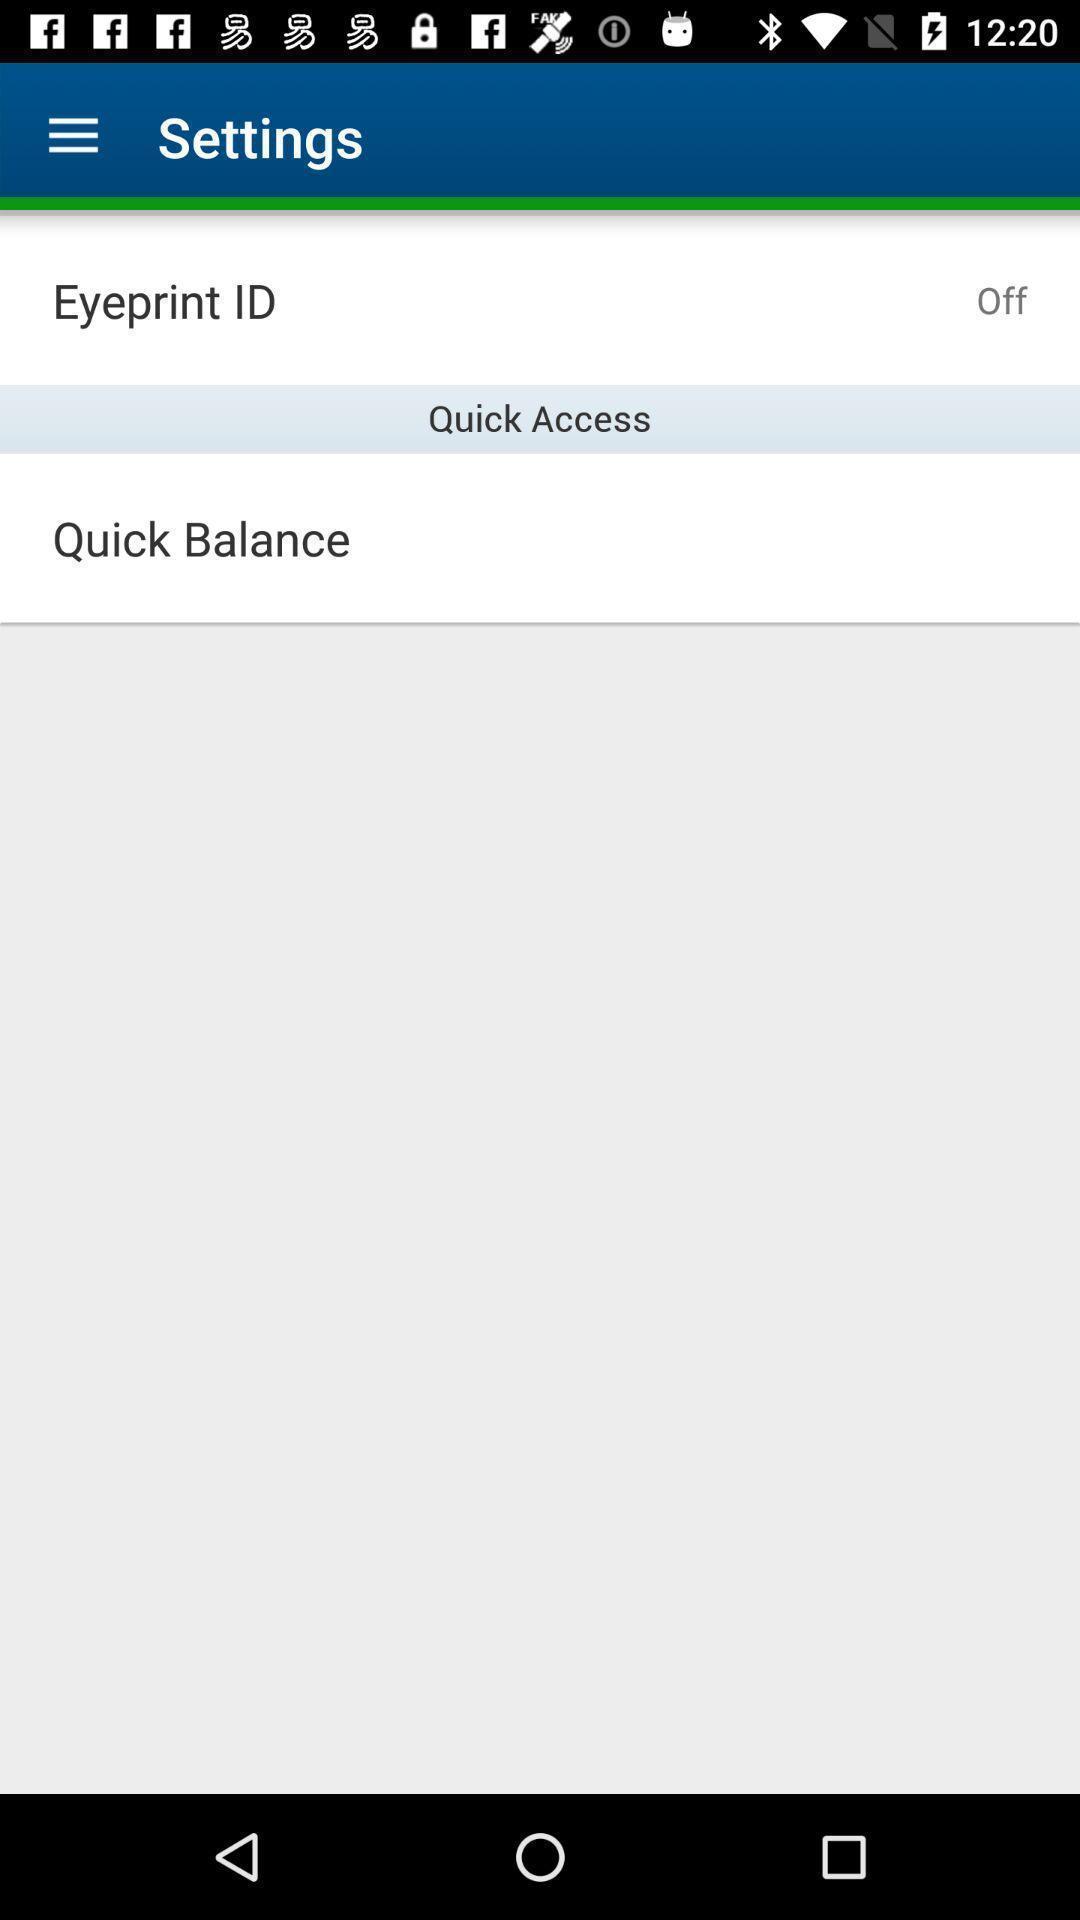Summarize the information in this screenshot. Settings page displaying various options. 